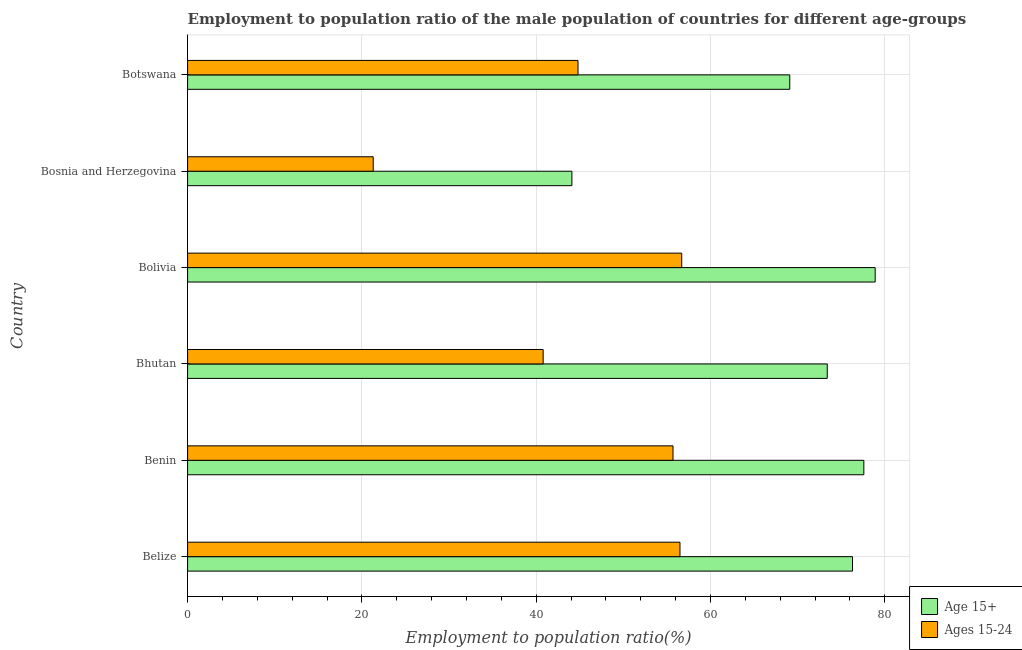How many groups of bars are there?
Ensure brevity in your answer.  6. Are the number of bars on each tick of the Y-axis equal?
Your answer should be very brief. Yes. How many bars are there on the 3rd tick from the bottom?
Make the answer very short. 2. What is the label of the 1st group of bars from the top?
Your response must be concise. Botswana. In how many cases, is the number of bars for a given country not equal to the number of legend labels?
Provide a succinct answer. 0. What is the employment to population ratio(age 15-24) in Benin?
Give a very brief answer. 55.7. Across all countries, what is the maximum employment to population ratio(age 15-24)?
Your response must be concise. 56.7. Across all countries, what is the minimum employment to population ratio(age 15+)?
Offer a terse response. 44.1. In which country was the employment to population ratio(age 15-24) minimum?
Give a very brief answer. Bosnia and Herzegovina. What is the total employment to population ratio(age 15-24) in the graph?
Keep it short and to the point. 275.8. What is the difference between the employment to population ratio(age 15+) in Belize and that in Benin?
Offer a very short reply. -1.3. What is the difference between the employment to population ratio(age 15+) in Bhutan and the employment to population ratio(age 15-24) in Benin?
Your response must be concise. 17.7. What is the average employment to population ratio(age 15+) per country?
Offer a very short reply. 69.9. What is the difference between the employment to population ratio(age 15+) and employment to population ratio(age 15-24) in Bhutan?
Ensure brevity in your answer.  32.6. In how many countries, is the employment to population ratio(age 15+) greater than 12 %?
Your answer should be very brief. 6. What is the ratio of the employment to population ratio(age 15+) in Bolivia to that in Bosnia and Herzegovina?
Make the answer very short. 1.79. Is the difference between the employment to population ratio(age 15+) in Bhutan and Botswana greater than the difference between the employment to population ratio(age 15-24) in Bhutan and Botswana?
Make the answer very short. Yes. What is the difference between the highest and the lowest employment to population ratio(age 15-24)?
Your response must be concise. 35.4. In how many countries, is the employment to population ratio(age 15-24) greater than the average employment to population ratio(age 15-24) taken over all countries?
Make the answer very short. 3. Is the sum of the employment to population ratio(age 15-24) in Bhutan and Bosnia and Herzegovina greater than the maximum employment to population ratio(age 15+) across all countries?
Offer a very short reply. No. What does the 1st bar from the top in Belize represents?
Your answer should be very brief. Ages 15-24. What does the 2nd bar from the bottom in Belize represents?
Offer a terse response. Ages 15-24. How many bars are there?
Your answer should be compact. 12. How many countries are there in the graph?
Offer a terse response. 6. What is the difference between two consecutive major ticks on the X-axis?
Offer a terse response. 20. Are the values on the major ticks of X-axis written in scientific E-notation?
Ensure brevity in your answer.  No. Does the graph contain any zero values?
Keep it short and to the point. No. How many legend labels are there?
Your response must be concise. 2. What is the title of the graph?
Your response must be concise. Employment to population ratio of the male population of countries for different age-groups. What is the label or title of the X-axis?
Give a very brief answer. Employment to population ratio(%). What is the label or title of the Y-axis?
Provide a succinct answer. Country. What is the Employment to population ratio(%) in Age 15+ in Belize?
Keep it short and to the point. 76.3. What is the Employment to population ratio(%) in Ages 15-24 in Belize?
Provide a succinct answer. 56.5. What is the Employment to population ratio(%) in Age 15+ in Benin?
Give a very brief answer. 77.6. What is the Employment to population ratio(%) in Ages 15-24 in Benin?
Offer a very short reply. 55.7. What is the Employment to population ratio(%) in Age 15+ in Bhutan?
Your answer should be compact. 73.4. What is the Employment to population ratio(%) in Ages 15-24 in Bhutan?
Your answer should be compact. 40.8. What is the Employment to population ratio(%) of Age 15+ in Bolivia?
Offer a very short reply. 78.9. What is the Employment to population ratio(%) in Ages 15-24 in Bolivia?
Your answer should be compact. 56.7. What is the Employment to population ratio(%) in Age 15+ in Bosnia and Herzegovina?
Make the answer very short. 44.1. What is the Employment to population ratio(%) of Ages 15-24 in Bosnia and Herzegovina?
Provide a short and direct response. 21.3. What is the Employment to population ratio(%) of Age 15+ in Botswana?
Give a very brief answer. 69.1. What is the Employment to population ratio(%) of Ages 15-24 in Botswana?
Provide a succinct answer. 44.8. Across all countries, what is the maximum Employment to population ratio(%) of Age 15+?
Give a very brief answer. 78.9. Across all countries, what is the maximum Employment to population ratio(%) of Ages 15-24?
Keep it short and to the point. 56.7. Across all countries, what is the minimum Employment to population ratio(%) of Age 15+?
Ensure brevity in your answer.  44.1. Across all countries, what is the minimum Employment to population ratio(%) of Ages 15-24?
Offer a terse response. 21.3. What is the total Employment to population ratio(%) of Age 15+ in the graph?
Offer a very short reply. 419.4. What is the total Employment to population ratio(%) in Ages 15-24 in the graph?
Offer a very short reply. 275.8. What is the difference between the Employment to population ratio(%) of Ages 15-24 in Belize and that in Benin?
Keep it short and to the point. 0.8. What is the difference between the Employment to population ratio(%) of Age 15+ in Belize and that in Bhutan?
Offer a terse response. 2.9. What is the difference between the Employment to population ratio(%) in Ages 15-24 in Belize and that in Bhutan?
Your answer should be very brief. 15.7. What is the difference between the Employment to population ratio(%) in Age 15+ in Belize and that in Bolivia?
Give a very brief answer. -2.6. What is the difference between the Employment to population ratio(%) of Ages 15-24 in Belize and that in Bolivia?
Provide a short and direct response. -0.2. What is the difference between the Employment to population ratio(%) in Age 15+ in Belize and that in Bosnia and Herzegovina?
Your answer should be very brief. 32.2. What is the difference between the Employment to population ratio(%) of Ages 15-24 in Belize and that in Bosnia and Herzegovina?
Make the answer very short. 35.2. What is the difference between the Employment to population ratio(%) in Age 15+ in Belize and that in Botswana?
Your answer should be very brief. 7.2. What is the difference between the Employment to population ratio(%) in Ages 15-24 in Benin and that in Bhutan?
Keep it short and to the point. 14.9. What is the difference between the Employment to population ratio(%) of Age 15+ in Benin and that in Bolivia?
Your answer should be compact. -1.3. What is the difference between the Employment to population ratio(%) of Age 15+ in Benin and that in Bosnia and Herzegovina?
Your answer should be very brief. 33.5. What is the difference between the Employment to population ratio(%) in Ages 15-24 in Benin and that in Bosnia and Herzegovina?
Make the answer very short. 34.4. What is the difference between the Employment to population ratio(%) of Age 15+ in Benin and that in Botswana?
Make the answer very short. 8.5. What is the difference between the Employment to population ratio(%) of Ages 15-24 in Benin and that in Botswana?
Provide a short and direct response. 10.9. What is the difference between the Employment to population ratio(%) in Ages 15-24 in Bhutan and that in Bolivia?
Give a very brief answer. -15.9. What is the difference between the Employment to population ratio(%) of Age 15+ in Bhutan and that in Bosnia and Herzegovina?
Offer a very short reply. 29.3. What is the difference between the Employment to population ratio(%) of Age 15+ in Bhutan and that in Botswana?
Your answer should be compact. 4.3. What is the difference between the Employment to population ratio(%) of Ages 15-24 in Bhutan and that in Botswana?
Make the answer very short. -4. What is the difference between the Employment to population ratio(%) in Age 15+ in Bolivia and that in Bosnia and Herzegovina?
Offer a very short reply. 34.8. What is the difference between the Employment to population ratio(%) of Ages 15-24 in Bolivia and that in Bosnia and Herzegovina?
Provide a short and direct response. 35.4. What is the difference between the Employment to population ratio(%) of Age 15+ in Bolivia and that in Botswana?
Provide a short and direct response. 9.8. What is the difference between the Employment to population ratio(%) of Ages 15-24 in Bolivia and that in Botswana?
Provide a short and direct response. 11.9. What is the difference between the Employment to population ratio(%) in Ages 15-24 in Bosnia and Herzegovina and that in Botswana?
Your answer should be very brief. -23.5. What is the difference between the Employment to population ratio(%) of Age 15+ in Belize and the Employment to population ratio(%) of Ages 15-24 in Benin?
Ensure brevity in your answer.  20.6. What is the difference between the Employment to population ratio(%) of Age 15+ in Belize and the Employment to population ratio(%) of Ages 15-24 in Bhutan?
Provide a short and direct response. 35.5. What is the difference between the Employment to population ratio(%) of Age 15+ in Belize and the Employment to population ratio(%) of Ages 15-24 in Bolivia?
Give a very brief answer. 19.6. What is the difference between the Employment to population ratio(%) of Age 15+ in Belize and the Employment to population ratio(%) of Ages 15-24 in Bosnia and Herzegovina?
Make the answer very short. 55. What is the difference between the Employment to population ratio(%) in Age 15+ in Belize and the Employment to population ratio(%) in Ages 15-24 in Botswana?
Your response must be concise. 31.5. What is the difference between the Employment to population ratio(%) of Age 15+ in Benin and the Employment to population ratio(%) of Ages 15-24 in Bhutan?
Offer a terse response. 36.8. What is the difference between the Employment to population ratio(%) in Age 15+ in Benin and the Employment to population ratio(%) in Ages 15-24 in Bolivia?
Give a very brief answer. 20.9. What is the difference between the Employment to population ratio(%) of Age 15+ in Benin and the Employment to population ratio(%) of Ages 15-24 in Bosnia and Herzegovina?
Your answer should be compact. 56.3. What is the difference between the Employment to population ratio(%) in Age 15+ in Benin and the Employment to population ratio(%) in Ages 15-24 in Botswana?
Make the answer very short. 32.8. What is the difference between the Employment to population ratio(%) in Age 15+ in Bhutan and the Employment to population ratio(%) in Ages 15-24 in Bolivia?
Make the answer very short. 16.7. What is the difference between the Employment to population ratio(%) in Age 15+ in Bhutan and the Employment to population ratio(%) in Ages 15-24 in Bosnia and Herzegovina?
Your answer should be compact. 52.1. What is the difference between the Employment to population ratio(%) in Age 15+ in Bhutan and the Employment to population ratio(%) in Ages 15-24 in Botswana?
Your answer should be compact. 28.6. What is the difference between the Employment to population ratio(%) in Age 15+ in Bolivia and the Employment to population ratio(%) in Ages 15-24 in Bosnia and Herzegovina?
Your answer should be very brief. 57.6. What is the difference between the Employment to population ratio(%) of Age 15+ in Bolivia and the Employment to population ratio(%) of Ages 15-24 in Botswana?
Ensure brevity in your answer.  34.1. What is the difference between the Employment to population ratio(%) in Age 15+ in Bosnia and Herzegovina and the Employment to population ratio(%) in Ages 15-24 in Botswana?
Your response must be concise. -0.7. What is the average Employment to population ratio(%) of Age 15+ per country?
Make the answer very short. 69.9. What is the average Employment to population ratio(%) in Ages 15-24 per country?
Make the answer very short. 45.97. What is the difference between the Employment to population ratio(%) of Age 15+ and Employment to population ratio(%) of Ages 15-24 in Belize?
Give a very brief answer. 19.8. What is the difference between the Employment to population ratio(%) in Age 15+ and Employment to population ratio(%) in Ages 15-24 in Benin?
Your answer should be compact. 21.9. What is the difference between the Employment to population ratio(%) in Age 15+ and Employment to population ratio(%) in Ages 15-24 in Bhutan?
Give a very brief answer. 32.6. What is the difference between the Employment to population ratio(%) of Age 15+ and Employment to population ratio(%) of Ages 15-24 in Bolivia?
Give a very brief answer. 22.2. What is the difference between the Employment to population ratio(%) in Age 15+ and Employment to population ratio(%) in Ages 15-24 in Bosnia and Herzegovina?
Provide a succinct answer. 22.8. What is the difference between the Employment to population ratio(%) in Age 15+ and Employment to population ratio(%) in Ages 15-24 in Botswana?
Your answer should be very brief. 24.3. What is the ratio of the Employment to population ratio(%) of Age 15+ in Belize to that in Benin?
Ensure brevity in your answer.  0.98. What is the ratio of the Employment to population ratio(%) of Ages 15-24 in Belize to that in Benin?
Your answer should be compact. 1.01. What is the ratio of the Employment to population ratio(%) in Age 15+ in Belize to that in Bhutan?
Give a very brief answer. 1.04. What is the ratio of the Employment to population ratio(%) of Ages 15-24 in Belize to that in Bhutan?
Your response must be concise. 1.38. What is the ratio of the Employment to population ratio(%) of Age 15+ in Belize to that in Bolivia?
Keep it short and to the point. 0.97. What is the ratio of the Employment to population ratio(%) in Ages 15-24 in Belize to that in Bolivia?
Offer a very short reply. 1. What is the ratio of the Employment to population ratio(%) in Age 15+ in Belize to that in Bosnia and Herzegovina?
Provide a short and direct response. 1.73. What is the ratio of the Employment to population ratio(%) in Ages 15-24 in Belize to that in Bosnia and Herzegovina?
Your response must be concise. 2.65. What is the ratio of the Employment to population ratio(%) of Age 15+ in Belize to that in Botswana?
Offer a terse response. 1.1. What is the ratio of the Employment to population ratio(%) of Ages 15-24 in Belize to that in Botswana?
Provide a succinct answer. 1.26. What is the ratio of the Employment to population ratio(%) in Age 15+ in Benin to that in Bhutan?
Ensure brevity in your answer.  1.06. What is the ratio of the Employment to population ratio(%) of Ages 15-24 in Benin to that in Bhutan?
Ensure brevity in your answer.  1.37. What is the ratio of the Employment to population ratio(%) in Age 15+ in Benin to that in Bolivia?
Offer a very short reply. 0.98. What is the ratio of the Employment to population ratio(%) of Ages 15-24 in Benin to that in Bolivia?
Your response must be concise. 0.98. What is the ratio of the Employment to population ratio(%) in Age 15+ in Benin to that in Bosnia and Herzegovina?
Keep it short and to the point. 1.76. What is the ratio of the Employment to population ratio(%) in Ages 15-24 in Benin to that in Bosnia and Herzegovina?
Keep it short and to the point. 2.62. What is the ratio of the Employment to population ratio(%) in Age 15+ in Benin to that in Botswana?
Your answer should be compact. 1.12. What is the ratio of the Employment to population ratio(%) in Ages 15-24 in Benin to that in Botswana?
Provide a succinct answer. 1.24. What is the ratio of the Employment to population ratio(%) in Age 15+ in Bhutan to that in Bolivia?
Offer a very short reply. 0.93. What is the ratio of the Employment to population ratio(%) in Ages 15-24 in Bhutan to that in Bolivia?
Your answer should be very brief. 0.72. What is the ratio of the Employment to population ratio(%) of Age 15+ in Bhutan to that in Bosnia and Herzegovina?
Your answer should be compact. 1.66. What is the ratio of the Employment to population ratio(%) in Ages 15-24 in Bhutan to that in Bosnia and Herzegovina?
Give a very brief answer. 1.92. What is the ratio of the Employment to population ratio(%) in Age 15+ in Bhutan to that in Botswana?
Provide a succinct answer. 1.06. What is the ratio of the Employment to population ratio(%) of Ages 15-24 in Bhutan to that in Botswana?
Provide a succinct answer. 0.91. What is the ratio of the Employment to population ratio(%) in Age 15+ in Bolivia to that in Bosnia and Herzegovina?
Keep it short and to the point. 1.79. What is the ratio of the Employment to population ratio(%) in Ages 15-24 in Bolivia to that in Bosnia and Herzegovina?
Your answer should be very brief. 2.66. What is the ratio of the Employment to population ratio(%) of Age 15+ in Bolivia to that in Botswana?
Give a very brief answer. 1.14. What is the ratio of the Employment to population ratio(%) of Ages 15-24 in Bolivia to that in Botswana?
Provide a short and direct response. 1.27. What is the ratio of the Employment to population ratio(%) of Age 15+ in Bosnia and Herzegovina to that in Botswana?
Provide a succinct answer. 0.64. What is the ratio of the Employment to population ratio(%) of Ages 15-24 in Bosnia and Herzegovina to that in Botswana?
Your response must be concise. 0.48. What is the difference between the highest and the second highest Employment to population ratio(%) of Ages 15-24?
Offer a very short reply. 0.2. What is the difference between the highest and the lowest Employment to population ratio(%) in Age 15+?
Your answer should be compact. 34.8. What is the difference between the highest and the lowest Employment to population ratio(%) in Ages 15-24?
Offer a terse response. 35.4. 